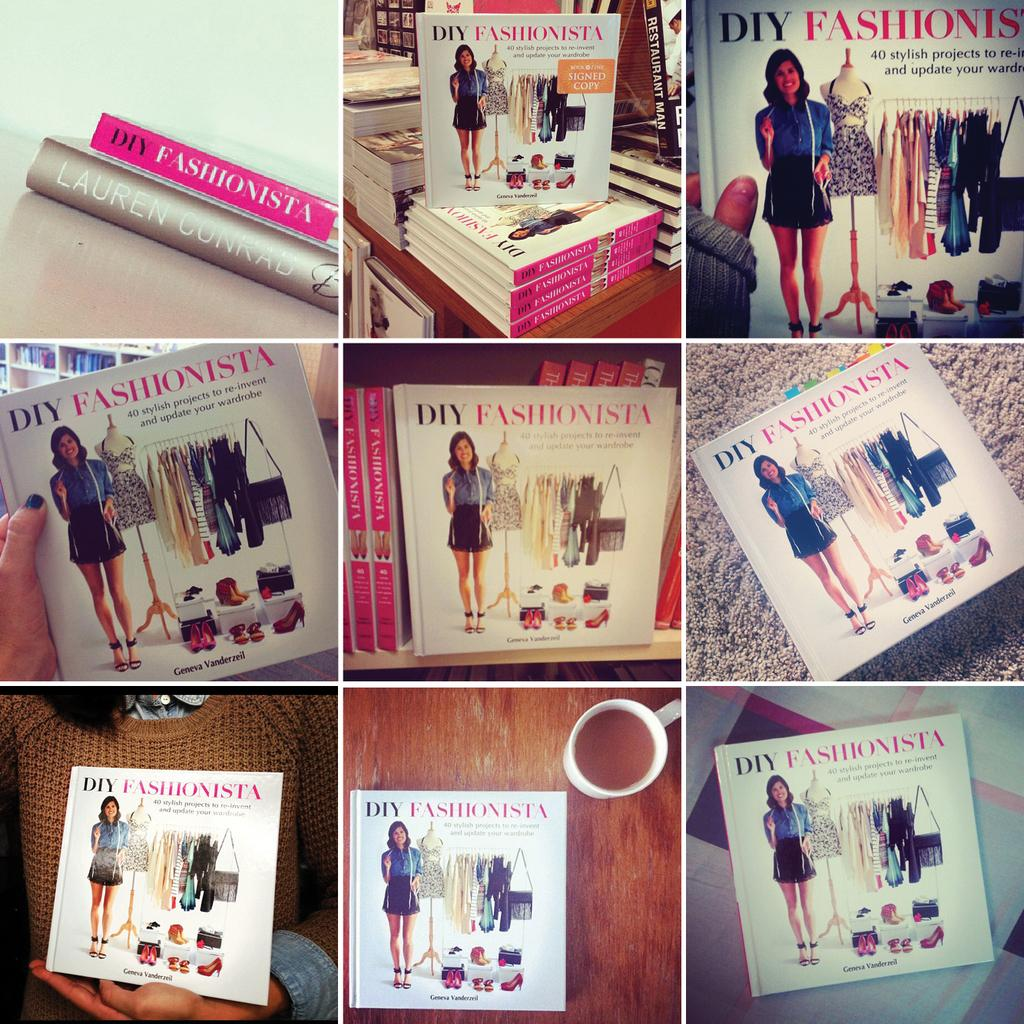What type of artwork is the image? The image is a collage. What items can be seen in the collage? There are books and a cup of tea on a wooden platform visible in the image. Can you describe the hands in the image? People's hands are visible in the image. What is a person doing with a book in the image? A person is holding a book in their hand. What type of beef is being served in the image? There is no beef present in the image; it features a collage with books, a cup of tea, and people's hands. 